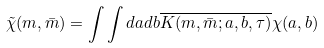<formula> <loc_0><loc_0><loc_500><loc_500>\tilde { \chi } ( m , \bar { m } ) = \int \int d a d b \overline { K ( m , \bar { m } ; a , b , \tau ) } \chi ( a , b )</formula> 